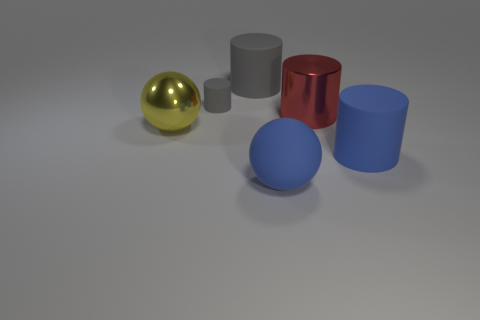Subtract all cyan cylinders. Subtract all purple blocks. How many cylinders are left? 4 Add 2 big yellow balls. How many objects exist? 8 Subtract all cylinders. How many objects are left? 2 Add 5 large gray rubber cylinders. How many large gray rubber cylinders are left? 6 Add 4 small cylinders. How many small cylinders exist? 5 Subtract 0 green cylinders. How many objects are left? 6 Subtract all large yellow things. Subtract all gray cylinders. How many objects are left? 3 